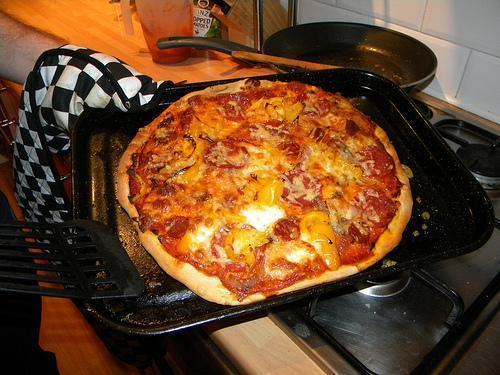How many pizzas are there?
Give a very brief answer. 1. 